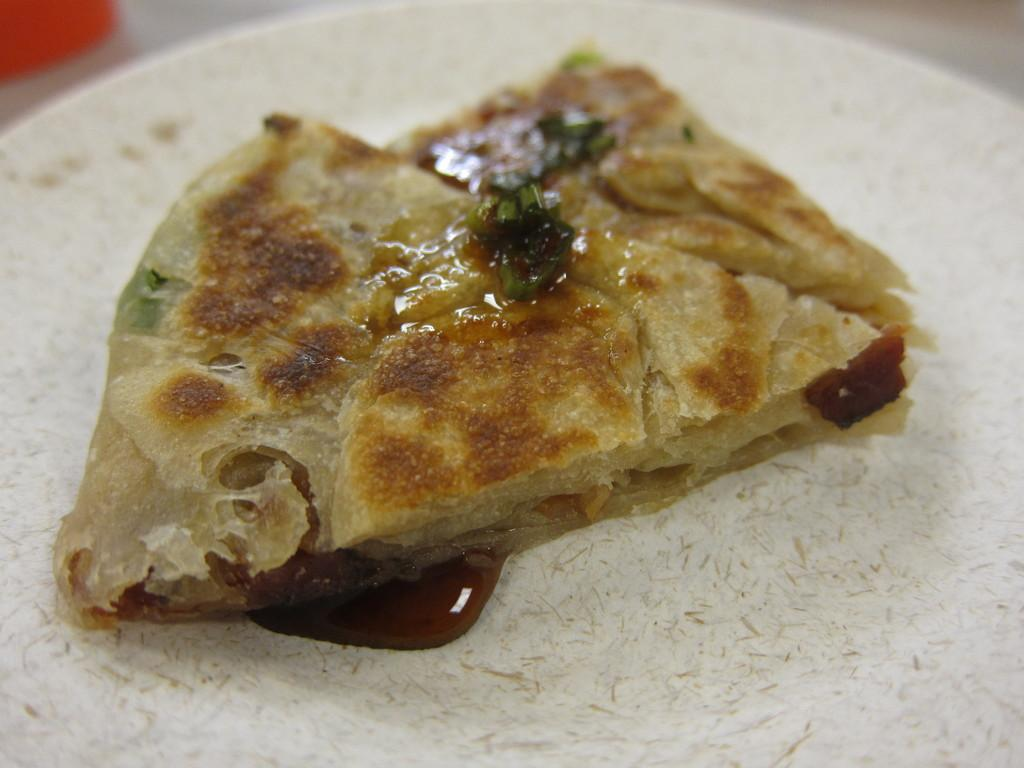What is the focus of the image? The image is zoomed in on a white color palette. What is on the palette? The palette contains a food item that seems to be a sandwich. How is the background of the image? The background of the image is blurry. Can you see any yokes in the image? There are no yokes present in the image. What type of knife is being used to cut the sandwich in the image? There is no knife visible in the image, as it is focused on the color palette and the sandwich. 